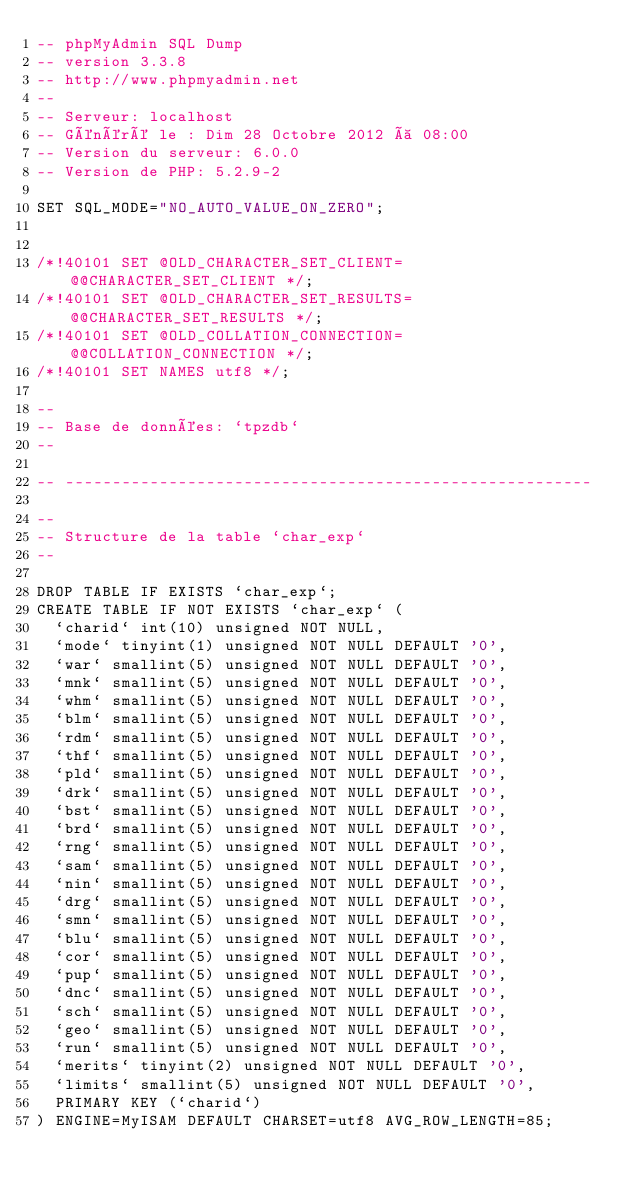<code> <loc_0><loc_0><loc_500><loc_500><_SQL_>-- phpMyAdmin SQL Dump
-- version 3.3.8
-- http://www.phpmyadmin.net
--
-- Serveur: localhost
-- Généré le : Dim 28 Octobre 2012 à 08:00
-- Version du serveur: 6.0.0
-- Version de PHP: 5.2.9-2

SET SQL_MODE="NO_AUTO_VALUE_ON_ZERO";


/*!40101 SET @OLD_CHARACTER_SET_CLIENT=@@CHARACTER_SET_CLIENT */;
/*!40101 SET @OLD_CHARACTER_SET_RESULTS=@@CHARACTER_SET_RESULTS */;
/*!40101 SET @OLD_COLLATION_CONNECTION=@@COLLATION_CONNECTION */;
/*!40101 SET NAMES utf8 */;

--
-- Base de données: `tpzdb`
--

-- --------------------------------------------------------

--
-- Structure de la table `char_exp`
--

DROP TABLE IF EXISTS `char_exp`;
CREATE TABLE IF NOT EXISTS `char_exp` (
  `charid` int(10) unsigned NOT NULL,
  `mode` tinyint(1) unsigned NOT NULL DEFAULT '0',
  `war` smallint(5) unsigned NOT NULL DEFAULT '0',
  `mnk` smallint(5) unsigned NOT NULL DEFAULT '0',
  `whm` smallint(5) unsigned NOT NULL DEFAULT '0',
  `blm` smallint(5) unsigned NOT NULL DEFAULT '0',
  `rdm` smallint(5) unsigned NOT NULL DEFAULT '0',
  `thf` smallint(5) unsigned NOT NULL DEFAULT '0',
  `pld` smallint(5) unsigned NOT NULL DEFAULT '0',
  `drk` smallint(5) unsigned NOT NULL DEFAULT '0',
  `bst` smallint(5) unsigned NOT NULL DEFAULT '0',
  `brd` smallint(5) unsigned NOT NULL DEFAULT '0',
  `rng` smallint(5) unsigned NOT NULL DEFAULT '0',
  `sam` smallint(5) unsigned NOT NULL DEFAULT '0',
  `nin` smallint(5) unsigned NOT NULL DEFAULT '0',
  `drg` smallint(5) unsigned NOT NULL DEFAULT '0',
  `smn` smallint(5) unsigned NOT NULL DEFAULT '0',
  `blu` smallint(5) unsigned NOT NULL DEFAULT '0',
  `cor` smallint(5) unsigned NOT NULL DEFAULT '0',
  `pup` smallint(5) unsigned NOT NULL DEFAULT '0',
  `dnc` smallint(5) unsigned NOT NULL DEFAULT '0',
  `sch` smallint(5) unsigned NOT NULL DEFAULT '0',
  `geo` smallint(5) unsigned NOT NULL DEFAULT '0',
  `run` smallint(5) unsigned NOT NULL DEFAULT '0',
  `merits` tinyint(2) unsigned NOT NULL DEFAULT '0',
  `limits` smallint(5) unsigned NOT NULL DEFAULT '0',
  PRIMARY KEY (`charid`)
) ENGINE=MyISAM DEFAULT CHARSET=utf8 AVG_ROW_LENGTH=85;
</code> 